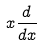<formula> <loc_0><loc_0><loc_500><loc_500>x \frac { d } { d x }</formula> 